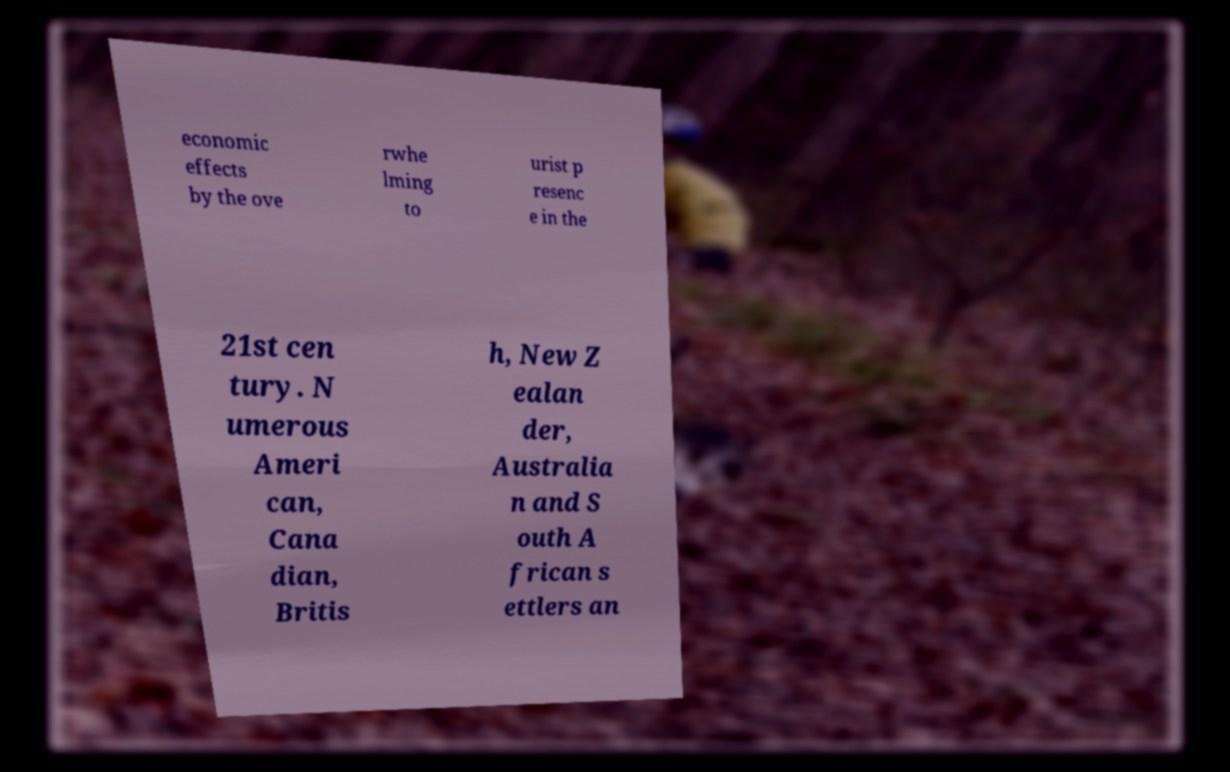For documentation purposes, I need the text within this image transcribed. Could you provide that? economic effects by the ove rwhe lming to urist p resenc e in the 21st cen tury. N umerous Ameri can, Cana dian, Britis h, New Z ealan der, Australia n and S outh A frican s ettlers an 